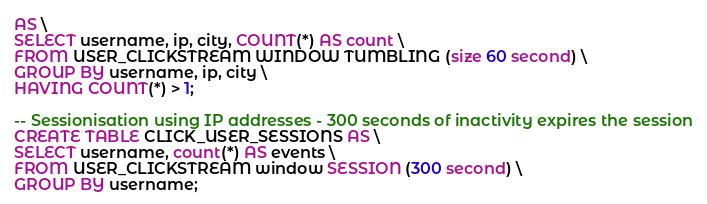<code> <loc_0><loc_0><loc_500><loc_500><_SQL_>AS \
SELECT username, ip, city, COUNT(*) AS count \
FROM USER_CLICKSTREAM WINDOW TUMBLING (size 60 second) \
GROUP BY username, ip, city \
HAVING COUNT(*) > 1;

-- Sessionisation using IP addresses - 300 seconds of inactivity expires the session
CREATE TABLE CLICK_USER_SESSIONS AS \
SELECT username, count(*) AS events \
FROM USER_CLICKSTREAM window SESSION (300 second) \
GROUP BY username;
</code> 